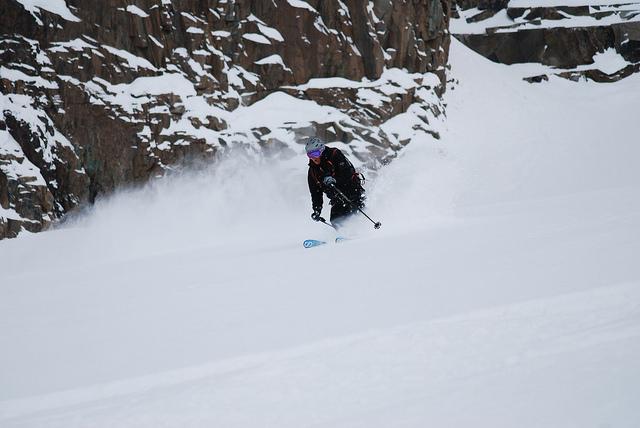Did this man fall?
Write a very short answer. No. Is the child on a conveyor belt?
Answer briefly. No. What season is this?
Be succinct. Winter. Is there snow on the ground?
Answer briefly. Yes. What is the man doing on the skis?
Quick response, please. Skiing. 